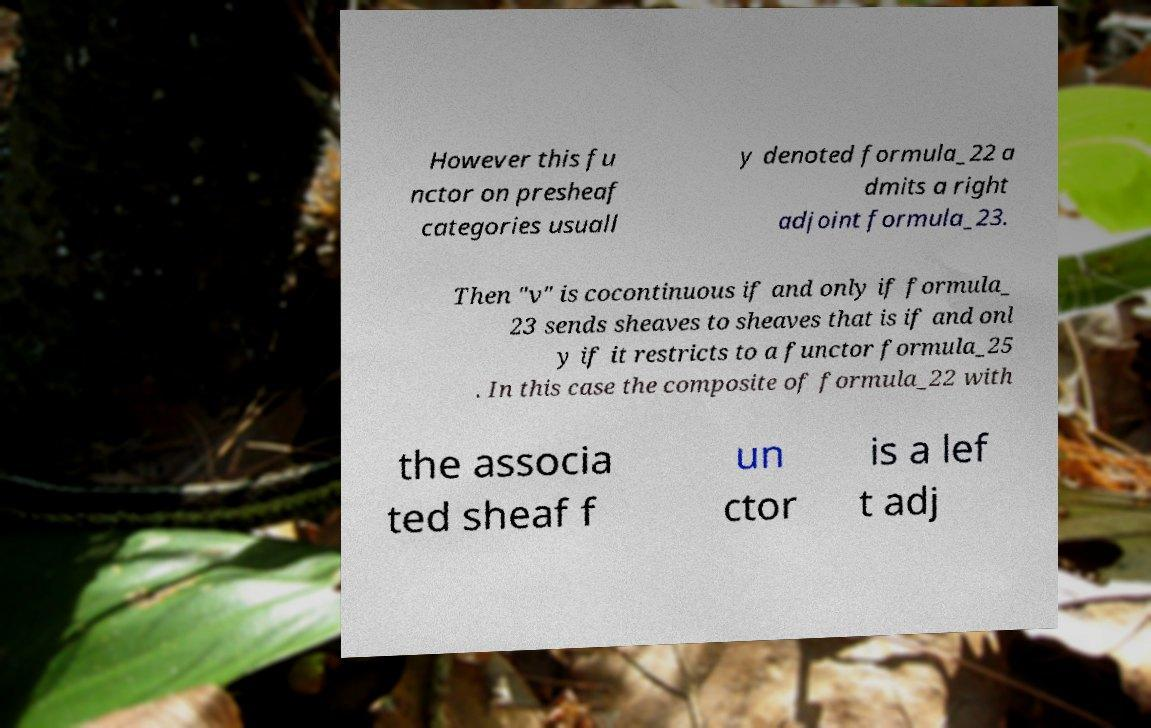What messages or text are displayed in this image? I need them in a readable, typed format. However this fu nctor on presheaf categories usuall y denoted formula_22 a dmits a right adjoint formula_23. Then "v" is cocontinuous if and only if formula_ 23 sends sheaves to sheaves that is if and onl y if it restricts to a functor formula_25 . In this case the composite of formula_22 with the associa ted sheaf f un ctor is a lef t adj 